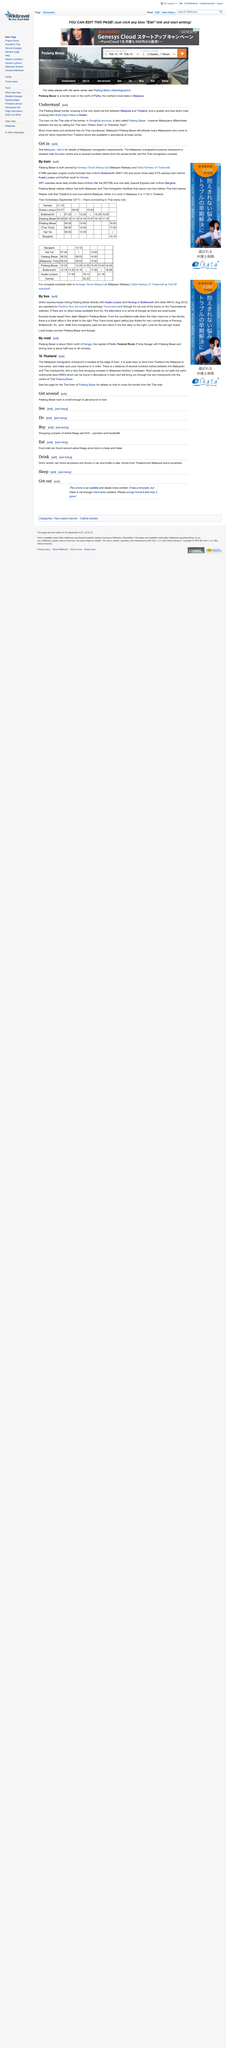Indicate a few pertinent items in this graphic. The Padang Besar is the only direct rail link between Malaysia and Thailand. If you are attempting to enter Malaysia, the Malaysian immigration/customs checkpoint can be found in the town center, conveniently located a few hundred meters from the border. In Malaysia, the town in Songkhla province is commonly referred to as "Pekan Siam" or "Siamese Town" by the locals. 